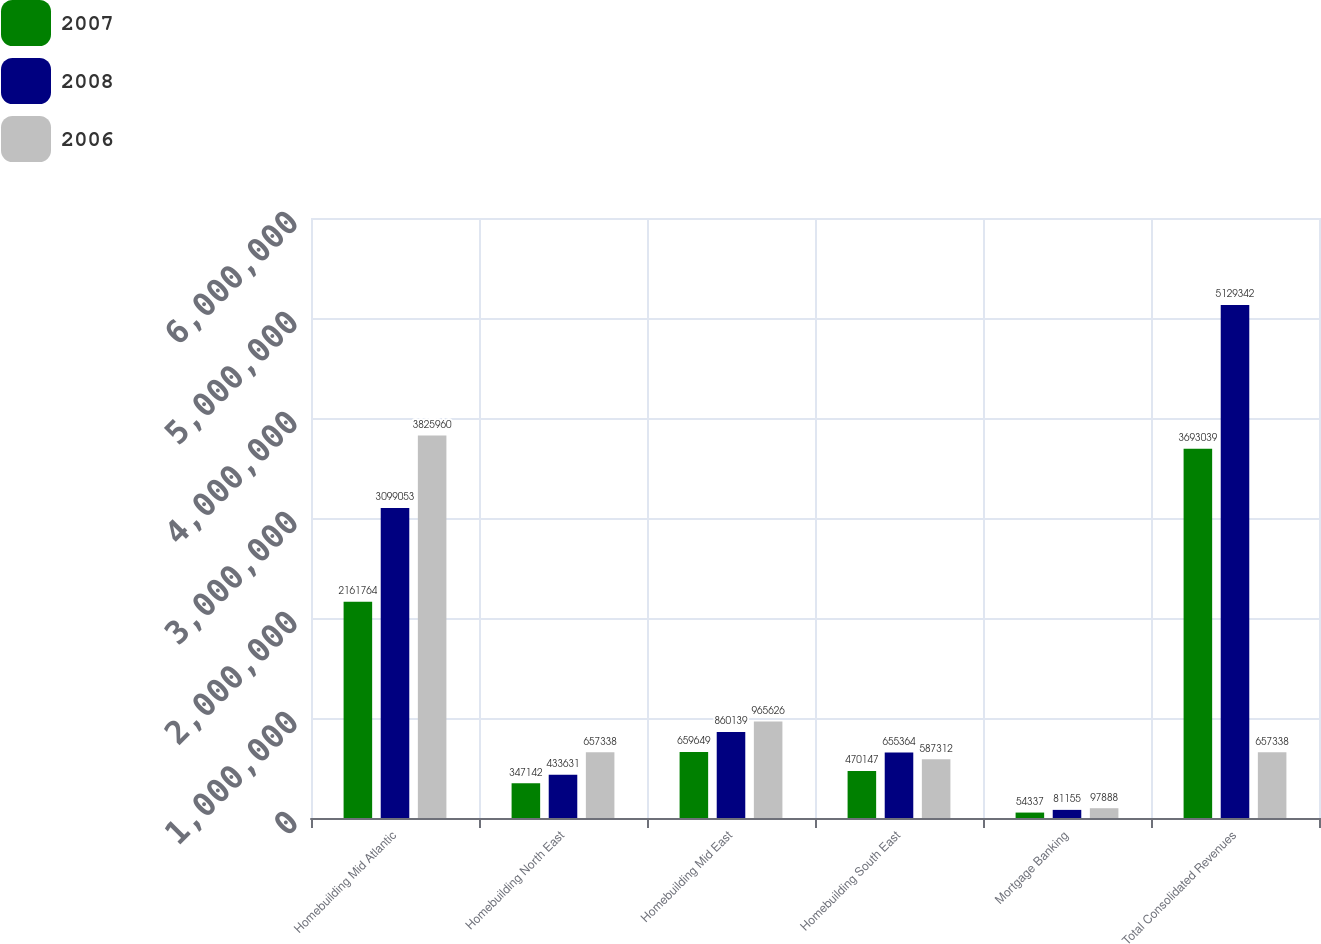Convert chart. <chart><loc_0><loc_0><loc_500><loc_500><stacked_bar_chart><ecel><fcel>Homebuilding Mid Atlantic<fcel>Homebuilding North East<fcel>Homebuilding Mid East<fcel>Homebuilding South East<fcel>Mortgage Banking<fcel>Total Consolidated Revenues<nl><fcel>2007<fcel>2.16176e+06<fcel>347142<fcel>659649<fcel>470147<fcel>54337<fcel>3.69304e+06<nl><fcel>2008<fcel>3.09905e+06<fcel>433631<fcel>860139<fcel>655364<fcel>81155<fcel>5.12934e+06<nl><fcel>2006<fcel>3.82596e+06<fcel>657338<fcel>965626<fcel>587312<fcel>97888<fcel>657338<nl></chart> 